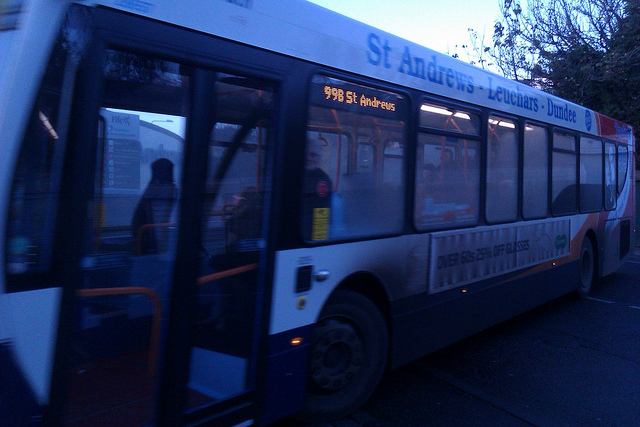Identify the text contained in this image. 99B St Andrews St Andrews Dundee Leuchars 